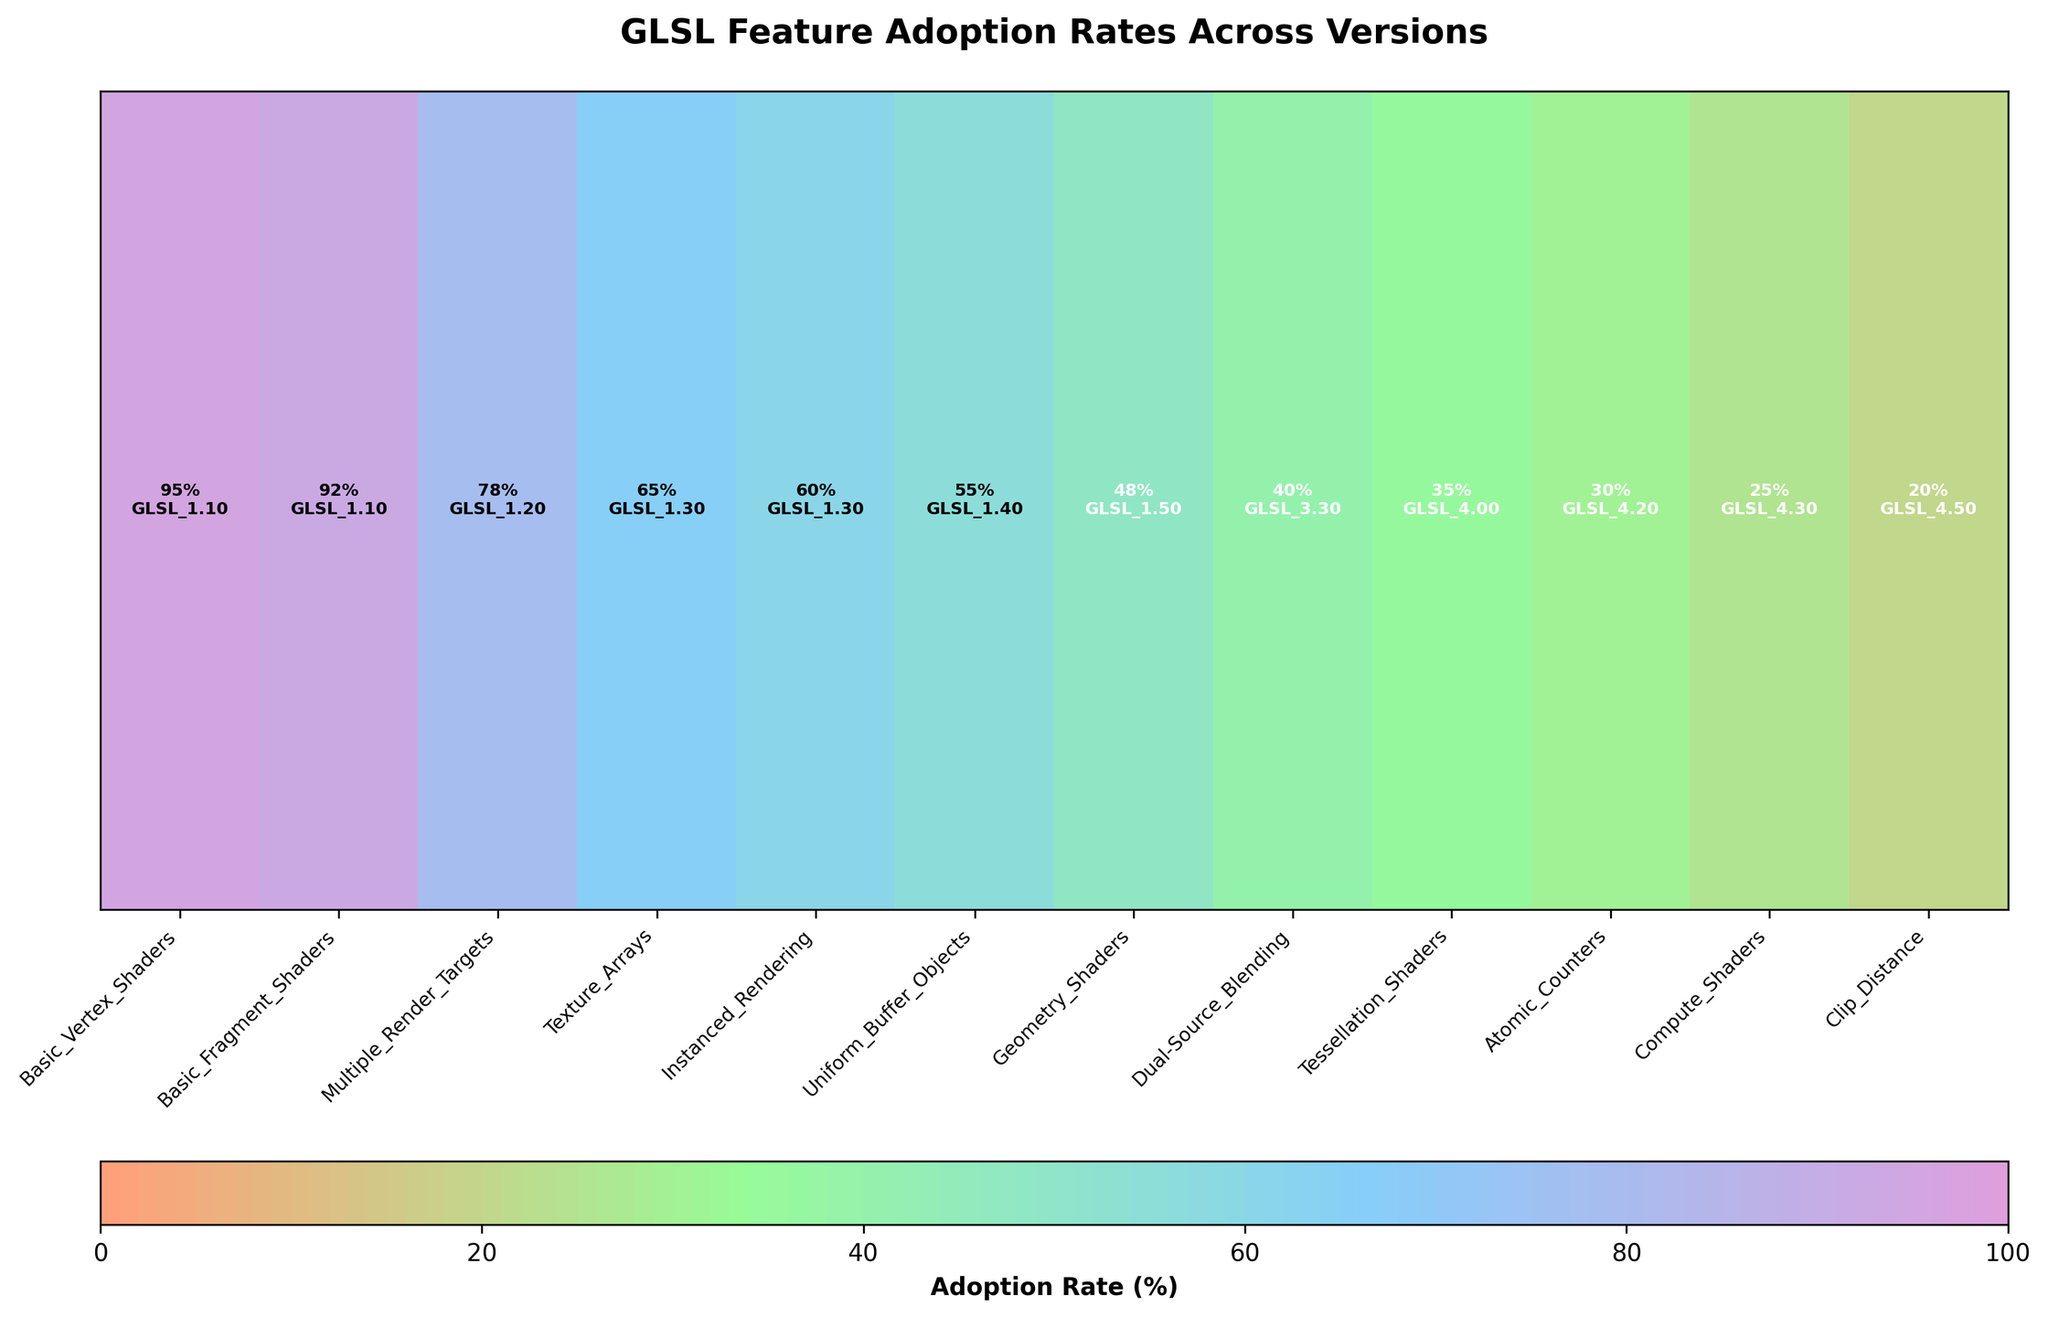What does the color bar represent in the plot? The color bar at the bottom of the plot represents the Adoption Rate (%) of GLSL features. The different colors correspond to different percentages, from minimum (0%) to maximum (100%).
Answer: Adoption Rate (%) Which GLSL version shows the highest adoption rate for any feature in this plot? Look for the feature with the darkest color (indicating the highest position on the color bar) and note the GLSL version annotated with it. The feature "Basic_Vertex_Shaders" shows the highest adoption rate (95%) for GLSL version 1.10.
Answer: GLSL 1.10 How many features in the plot have an adoption rate of 50% or less? Count the number of features where the percentage mentioned on the plot is 50 or less. The features are "Geometry_Shaders" (48%), "Dual-Source_Blending" (40%), "Tessellation_Shaders" (35%), "Atomic_Counters" (30%), "Compute_Shaders" (25%), and "Clip_Distance" (20%).
Answer: 6 What is the difference in adoption rate between "Basic_Vertex_Shaders" and "Compute_Shaders"? Find the adoption rates for both features, then subtract the smaller rate from the larger rate. "Basic_Vertex_Shaders" has an adoption rate of 95%, and "Compute_Shaders" has 25%. So, 95 - 25 = 70.
Answer: 70 Which feature has the lowest adoption rate and what is its corresponding GLSL version? Identify the feature with the lightest color indicating the lowest adoption rate. The feature "Clip_Distance" has the lowest adoption rate (20%) and is associated with GLSL version 4.50.
Answer: Clip_Distance, GLSL 4.50 Is the adoption rate for "Texture_Arrays" higher than that of "Instanced_Rendering"? Compare the adoption rates for both features. "Texture_Arrays" has an adoption rate of 65%, while "Instanced_Rendering" has 60%.
Answer: Yes What is the average adoption rate of features under GLSL 3.0? Identify the features and their adoption rates under GLSL 3.0 ("Texture_Arrays" and "Instanced_Rendering"), then calculate their average. (65 + 60) / 2 = 62.5.
Answer: 62.5 How does the adoption rate of "Uniform_Buffer_Objects" compare to "Multiple_Render_Targets"? Compare the adoption rates for both features. "Uniform_Buffer_Objects" has an adoption rate of 55%, whereas "Multiple_Render_Targets" has 78%. "Multiple_Render_Targets" has a higher adoption rate.
Answer: Lower What insights can we draw from the adoption rates of features from GLSL versions 1.10 to 1.50? Aggregate the adoption rates from these versions, note the rate percentages, and identify the trend. The features' rates are high, starting with GLSL 1.10 having 95% and 92%, then gradually decrease to 78%, 65%, and 60%. This suggests earlier versions have higher adoption rates than later ones within this range.
Answer: Higher adoption of early versions 